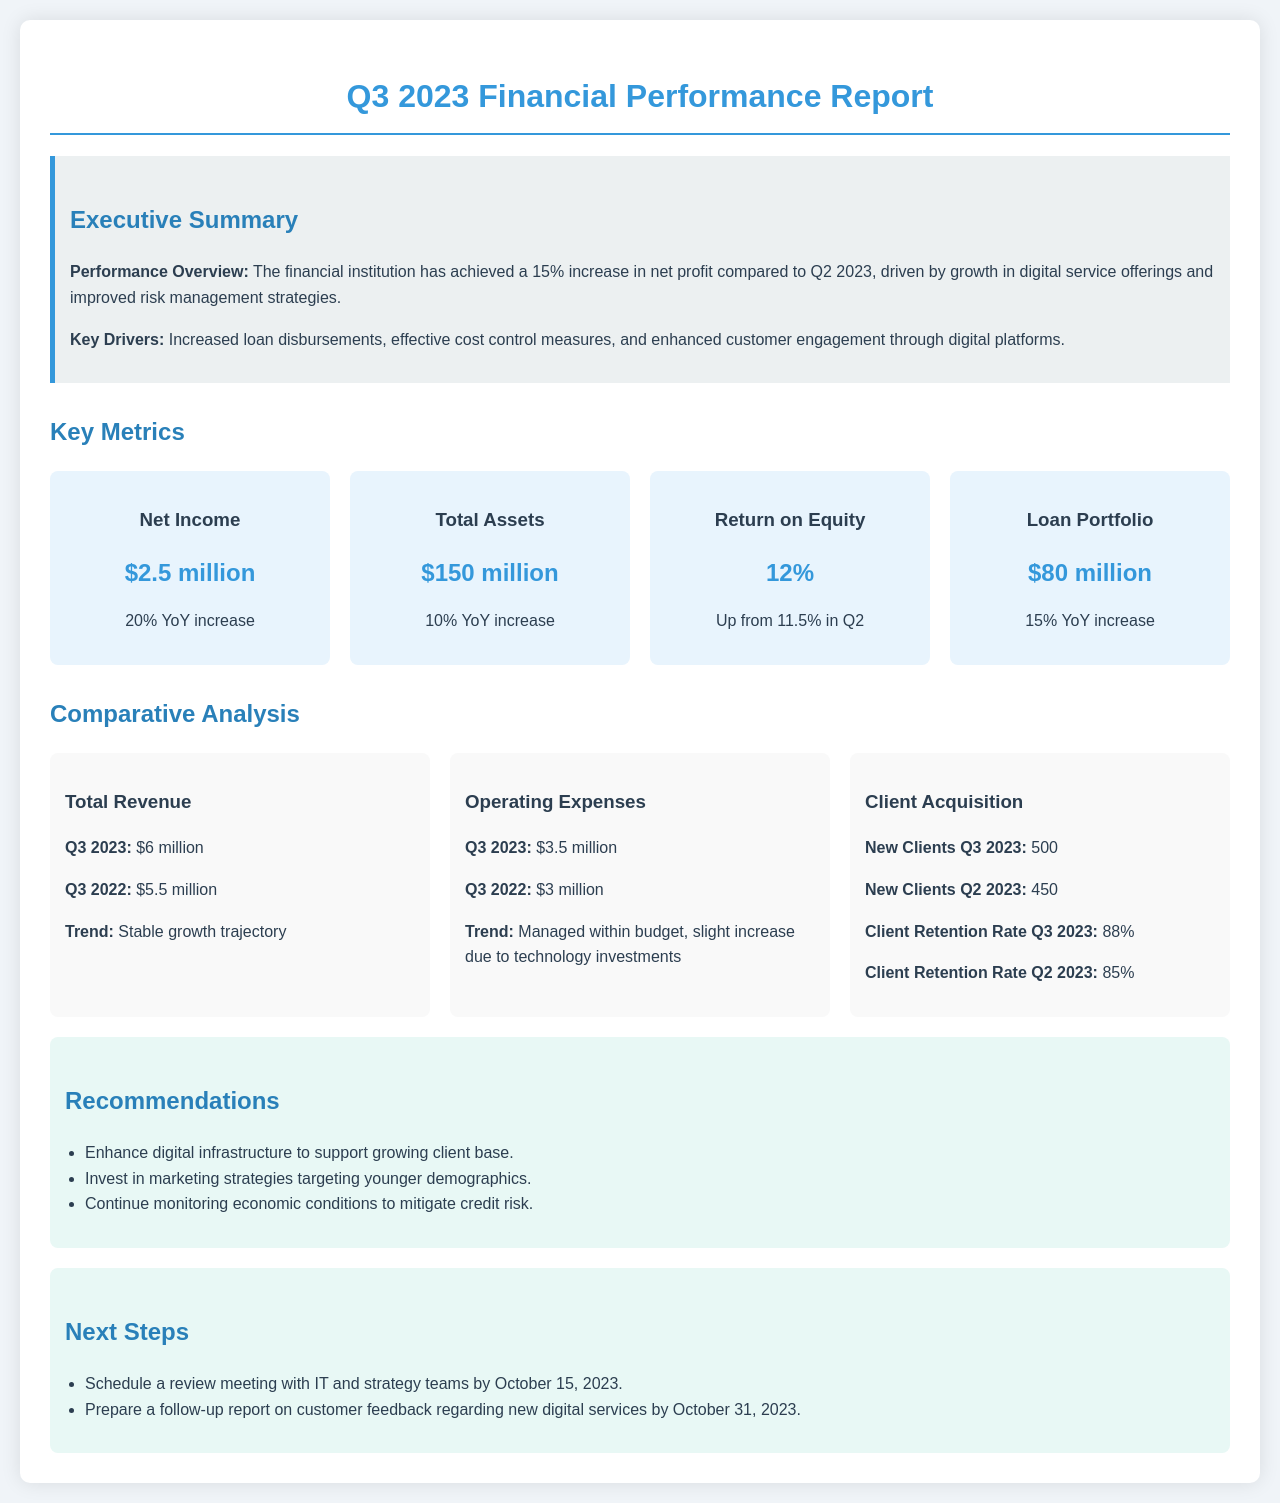What is the net income for Q3 2023? The net income is explicitly stated in the metrics section of the document.
Answer: $2.5 million What is the return on equity in Q3 2023? The return on equity is provided as one of the key metrics in the document.
Answer: 12% What was the total revenue for Q3 2022? The total revenue for Q3 2022 is mentioned in the comparative analysis section.
Answer: $5.5 million What was the new client acquisition number for Q2 2023? The new client acquisition number for Q2 2023 appears in the comparative analysis section under client acquisition.
Answer: 450 What is the client retention rate for Q3 2023? The client retention rate for Q3 2023 is highlighted in the comparative analysis section.
Answer: 88% What has driven the increase in net profit compared to Q2 2023? The executive summary outlines the key drivers affecting the net profit increase.
Answer: Growth in digital service offerings What trend is observed in total revenue compared to Q3 2022? The trend for total revenue is mentioned directly in the comparative analysis section.
Answer: Stable growth trajectory What is the total asset amount for Q3 2023? The total assets are clearly specified in the key metrics section of the document.
Answer: $150 million What technology-related factor influenced operating expenses? The comparative analysis section explains the impact of technology investments on operating expenses.
Answer: Slight increase due to technology investments 